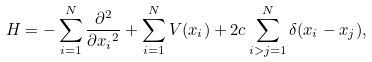<formula> <loc_0><loc_0><loc_500><loc_500>H = - \sum _ { i = 1 } ^ { N } \frac { \partial ^ { 2 } } { \partial { x _ { i } } ^ { 2 } } + \sum _ { i = 1 } ^ { N } V ( x _ { i } ) + 2 c \sum _ { i > j = 1 } ^ { N } \delta ( x _ { i } - x _ { j } ) ,</formula> 